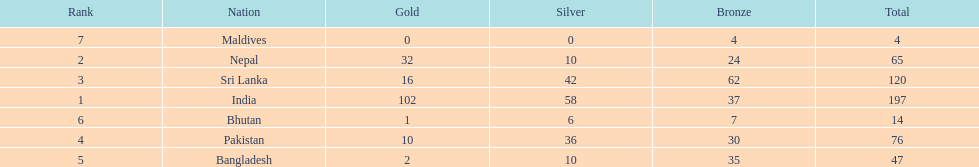Who has won the most bronze medals? Sri Lanka. I'm looking to parse the entire table for insights. Could you assist me with that? {'header': ['Rank', 'Nation', 'Gold', 'Silver', 'Bronze', 'Total'], 'rows': [['7', 'Maldives', '0', '0', '4', '4'], ['2', 'Nepal', '32', '10', '24', '65'], ['3', 'Sri Lanka', '16', '42', '62', '120'], ['1', 'India', '102', '58', '37', '197'], ['6', 'Bhutan', '1', '6', '7', '14'], ['4', 'Pakistan', '10', '36', '30', '76'], ['5', 'Bangladesh', '2', '10', '35', '47']]} 